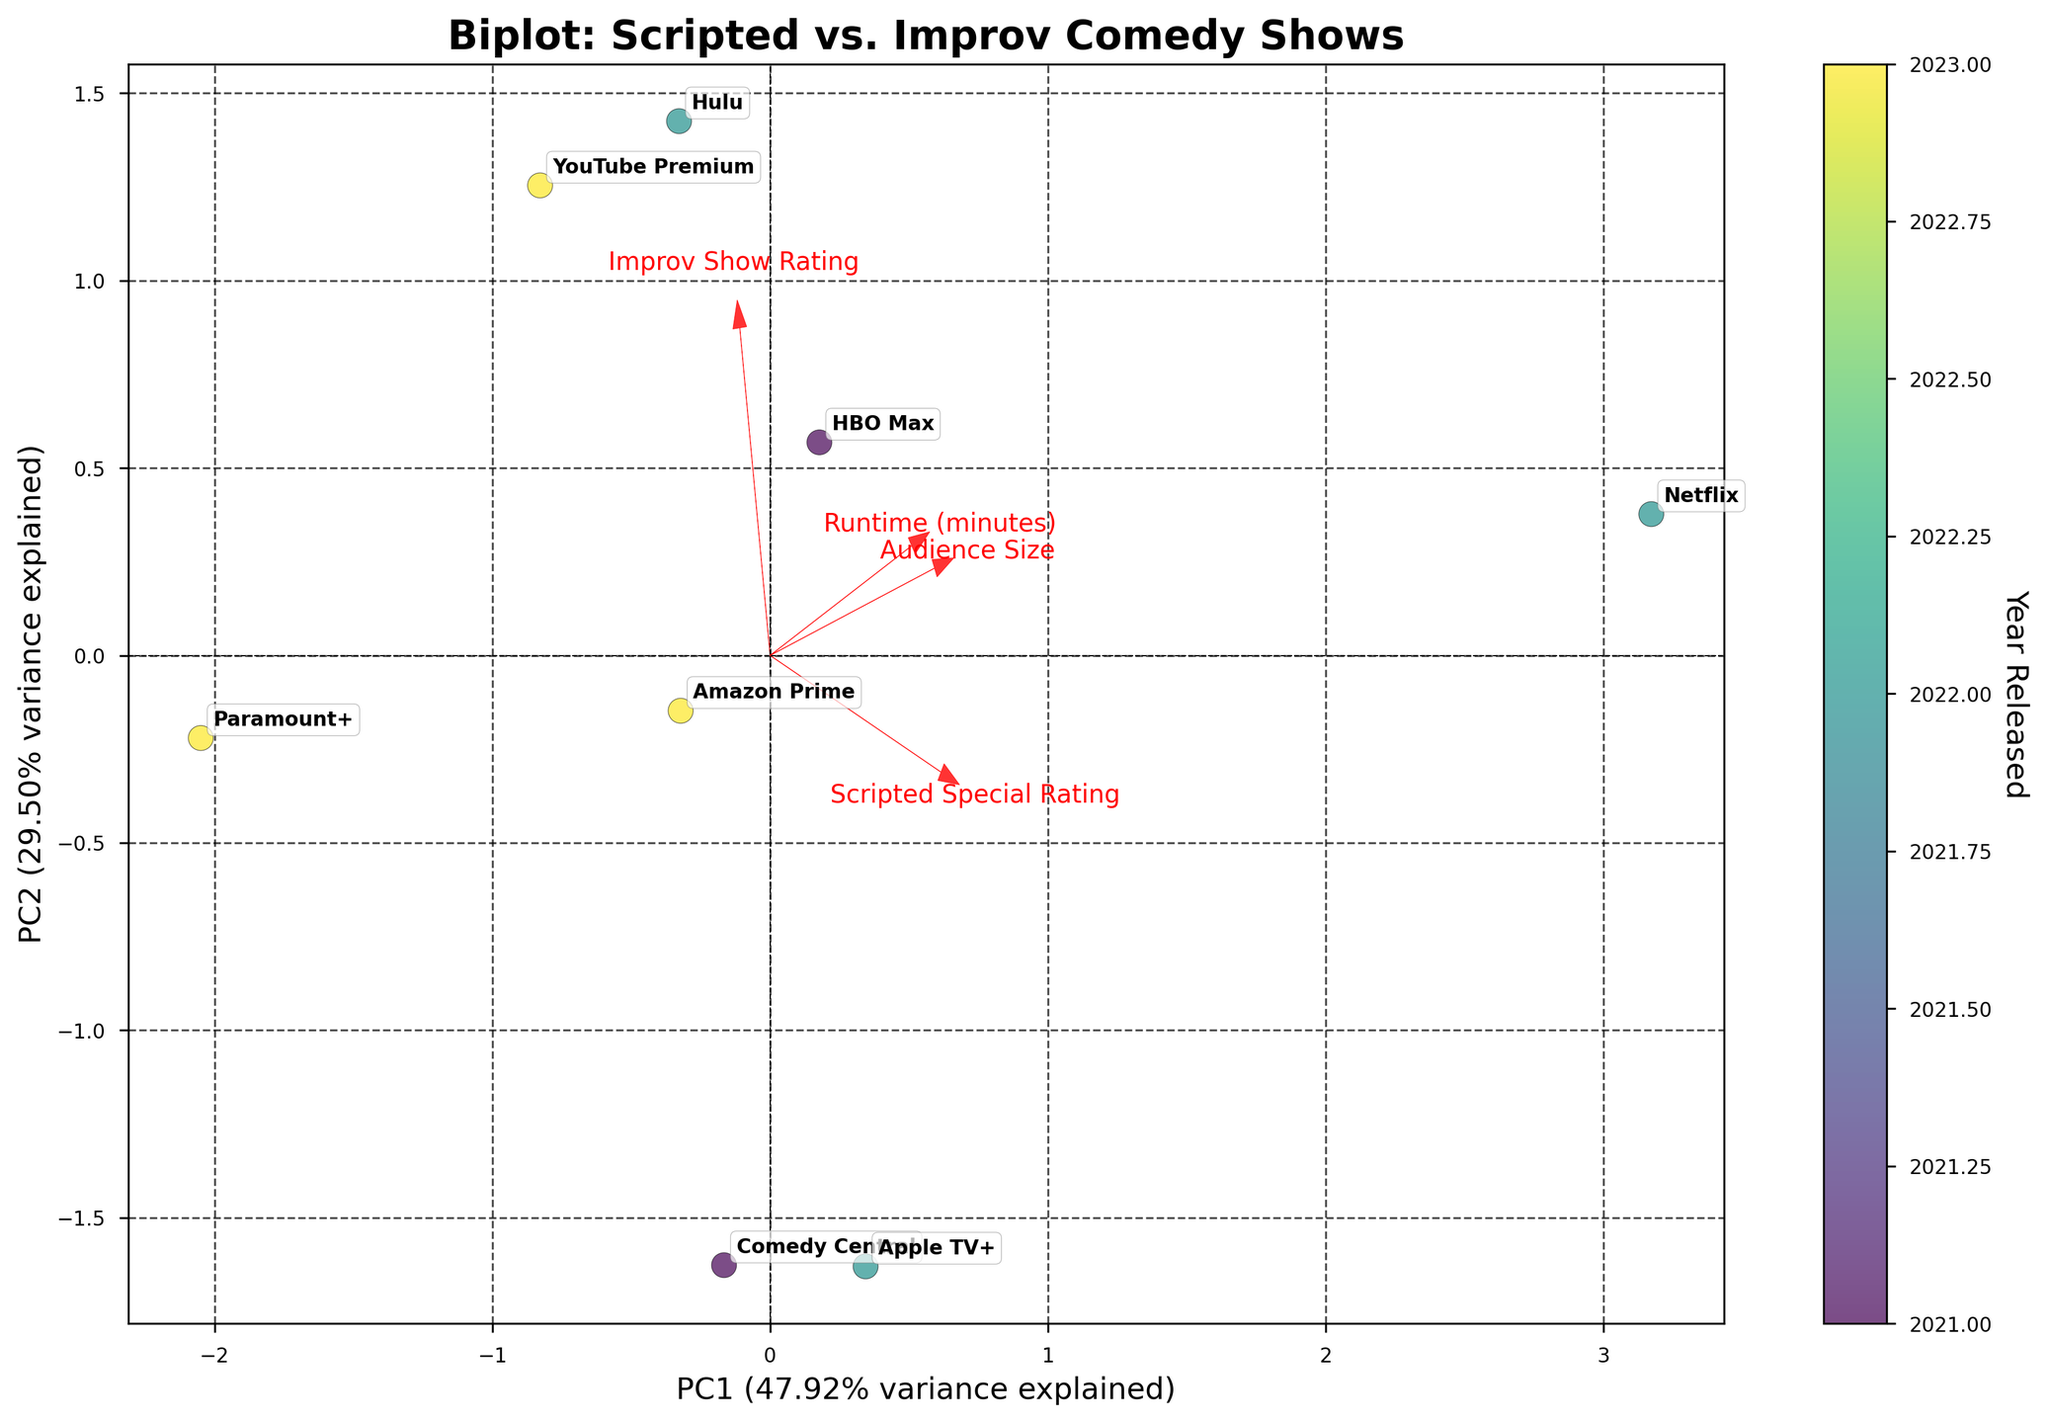What is the title of the plot? The title is always located at the top of the plot and gives an overview of what the visualization is about.
Answer: Biplot: Scripted vs. Improv Comedy Shows How many streaming platforms are represented in the plot? Each data point in the scatter plot corresponds to a streaming platform, labeled on the plot. By counting these labels, we can determine the number of platforms.
Answer: 8 Which platform had the highest scripted special rating? The platform with the highest scripted special rating will be farthest along the vector for "Scripted Special Rating." Using annotations on the plot, we can identify this platform.
Answer: Netflix Which year had the highest number of data points? Each point is colored according to the year it was released, and the color bar can help us identify the distribution of points across different years. By visually inspecting the color density, we can determine the year with the highest number of points.
Answer: 2022 Compare the audience sizes of Comedy Central and Apple TV+. Which one had a larger audience size? The platform closer to the vector for "Audience Size" (pointing outward from the origin in the direction indicating increased audience) can be identified. By looking at each platform's distance along this vector, we can compare the two.
Answer: Comedy Central What are the primary features represented by the two principal components (PC1 and PC2)? The vectors representing the original features help us understand what dominates each principal component. The length and orientation of these vectors relative to each axis indicate their influence.
Answer: Scripted Special Rating and Improv Show Rating Which platform is the most balanced between scripted and improv ratings? The balance can be identified by the position closest to the origin point where neither vector (Scripted Special Rating nor Improv Show Rating) is particularly dominant. By examining the scatter plot, we can locate this point.
Answer: Paramount+ How much variance is explained by the first principal component (PC1)? This information is labeled on the x-axis, where PC1 is defined. The percentage of variance explained is generally included in the axis label.
Answer: Approximately 61% Which platforms were released in 2023? Points in the scatter plot are colored according to their release year, with the color bar indicating which colors correspond to 2023. Annotations on these points will identify the platforms.
Answer: Amazon Prime, YouTube Premium, Paramount+ Which feature vector appears to have the least influence on the second principal component (PC2)? The influence of a feature vector on PC2 can be observed by its alignment with the y-axis. The vector with the shortest length or smallest projection on the y-axis has the least influence.
Answer: Scripted Special Rating 